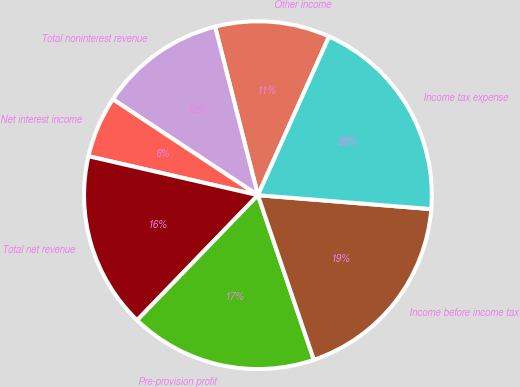Convert chart to OTSL. <chart><loc_0><loc_0><loc_500><loc_500><pie_chart><fcel>Other income<fcel>Total noninterest revenue<fcel>Net interest income<fcel>Total net revenue<fcel>Pre-provision profit<fcel>Income before income tax<fcel>Income tax expense<nl><fcel>10.67%<fcel>11.74%<fcel>5.7%<fcel>16.37%<fcel>17.44%<fcel>18.51%<fcel>19.57%<nl></chart> 